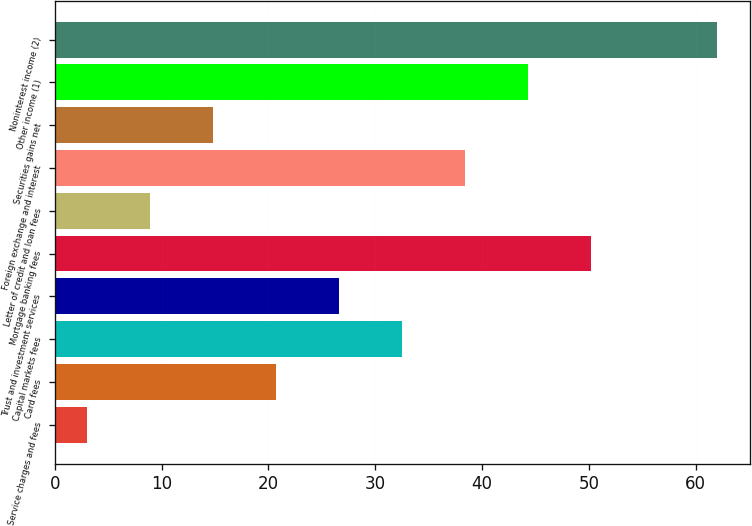Convert chart. <chart><loc_0><loc_0><loc_500><loc_500><bar_chart><fcel>Service charges and fees<fcel>Card fees<fcel>Capital markets fees<fcel>Trust and investment services<fcel>Mortgage banking fees<fcel>Letter of credit and loan fees<fcel>Foreign exchange and interest<fcel>Securities gains net<fcel>Other income (1)<fcel>Noninterest income (2)<nl><fcel>3<fcel>20.7<fcel>32.5<fcel>26.6<fcel>50.2<fcel>8.9<fcel>38.4<fcel>14.8<fcel>44.3<fcel>62<nl></chart> 